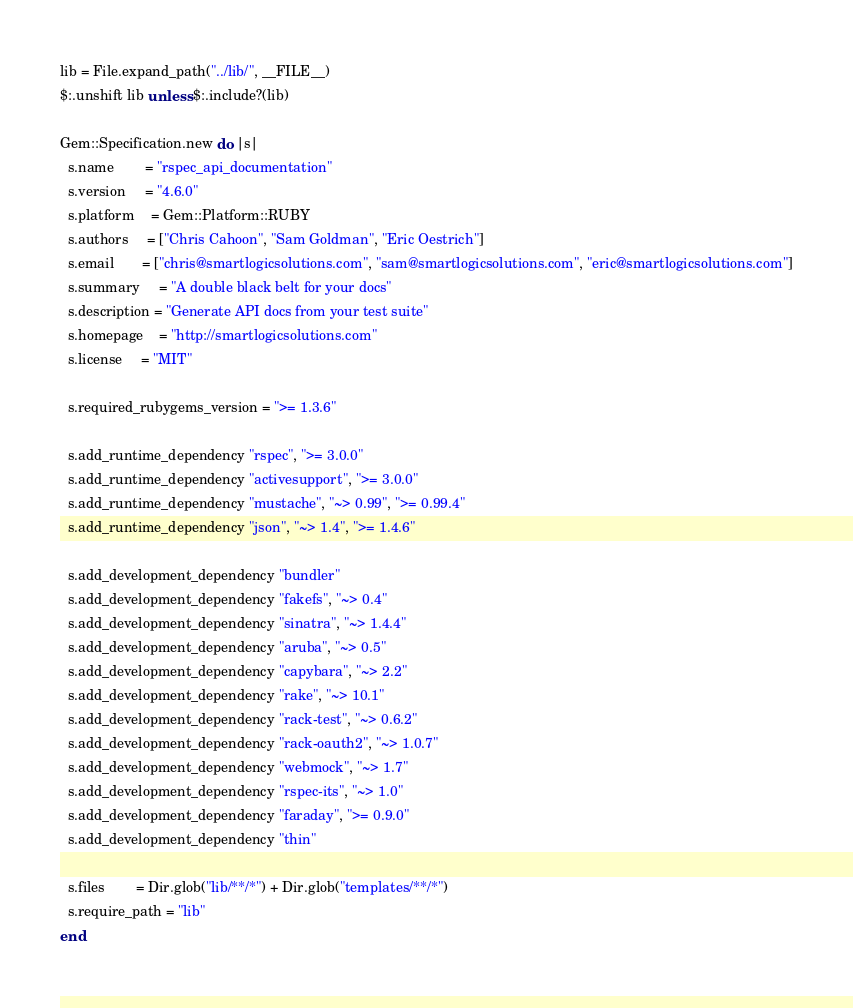Convert code to text. <code><loc_0><loc_0><loc_500><loc_500><_Ruby_>lib = File.expand_path("../lib/", __FILE__)
$:.unshift lib unless $:.include?(lib)

Gem::Specification.new do |s|
  s.name        = "rspec_api_documentation"
  s.version     = "4.6.0"
  s.platform    = Gem::Platform::RUBY
  s.authors     = ["Chris Cahoon", "Sam Goldman", "Eric Oestrich"]
  s.email       = ["chris@smartlogicsolutions.com", "sam@smartlogicsolutions.com", "eric@smartlogicsolutions.com"]
  s.summary     = "A double black belt for your docs"
  s.description = "Generate API docs from your test suite"
  s.homepage    = "http://smartlogicsolutions.com"
  s.license     = "MIT"

  s.required_rubygems_version = ">= 1.3.6"

  s.add_runtime_dependency "rspec", ">= 3.0.0"
  s.add_runtime_dependency "activesupport", ">= 3.0.0"
  s.add_runtime_dependency "mustache", "~> 0.99", ">= 0.99.4"
  s.add_runtime_dependency "json", "~> 1.4", ">= 1.4.6"

  s.add_development_dependency "bundler"
  s.add_development_dependency "fakefs", "~> 0.4"
  s.add_development_dependency "sinatra", "~> 1.4.4"
  s.add_development_dependency "aruba", "~> 0.5"
  s.add_development_dependency "capybara", "~> 2.2"
  s.add_development_dependency "rake", "~> 10.1"
  s.add_development_dependency "rack-test", "~> 0.6.2"
  s.add_development_dependency "rack-oauth2", "~> 1.0.7"
  s.add_development_dependency "webmock", "~> 1.7"
  s.add_development_dependency "rspec-its", "~> 1.0"
  s.add_development_dependency "faraday", ">= 0.9.0"
  s.add_development_dependency "thin"

  s.files        = Dir.glob("lib/**/*") + Dir.glob("templates/**/*")
  s.require_path = "lib"
end
</code> 